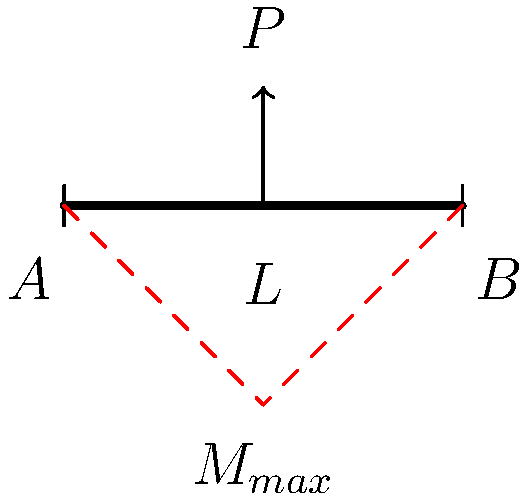In the context of structural analysis, consider a simply supported beam of length $L$ subjected to a point load $P$ at its midpoint. Given the bending moment diagram shown, what is the maximum bending moment $M_{max}$ in terms of $P$ and $L$? How might this analysis be relevant in assessing the structural integrity of public buildings to ensure compliance with safety regulations? To determine the maximum bending moment, we'll follow these steps:

1) For a simply supported beam with a point load at the center, the reactions at both supports (A and B) are equal due to symmetry:
   $R_A = R_B = \frac{P}{2}$

2) The maximum bending moment occurs at the point of load application (midpoint of the beam). We can calculate this using either support:

   $M_{max} = R_A \cdot \frac{L}{2} = \frac{P}{2} \cdot \frac{L}{2}$

3) Simplifying:
   $M_{max} = \frac{PL}{4}$

This analysis is crucial in assessing structural integrity because:

a) It helps determine the maximum stress in the beam, which is proportional to the bending moment.
b) Ensures the beam's design complies with building codes and safety factors.
c) Aids in selecting appropriate materials and beam dimensions to withstand expected loads.
d) Contributes to overall safety assessments of public buildings, which is essential for legal compliance and public safety regulations.

Understanding this principle allows for informed decision-making in policy proposals related to building safety and construction standards, ensuring they meet both engineering and legal requirements.
Answer: $M_{max} = \frac{PL}{4}$ 